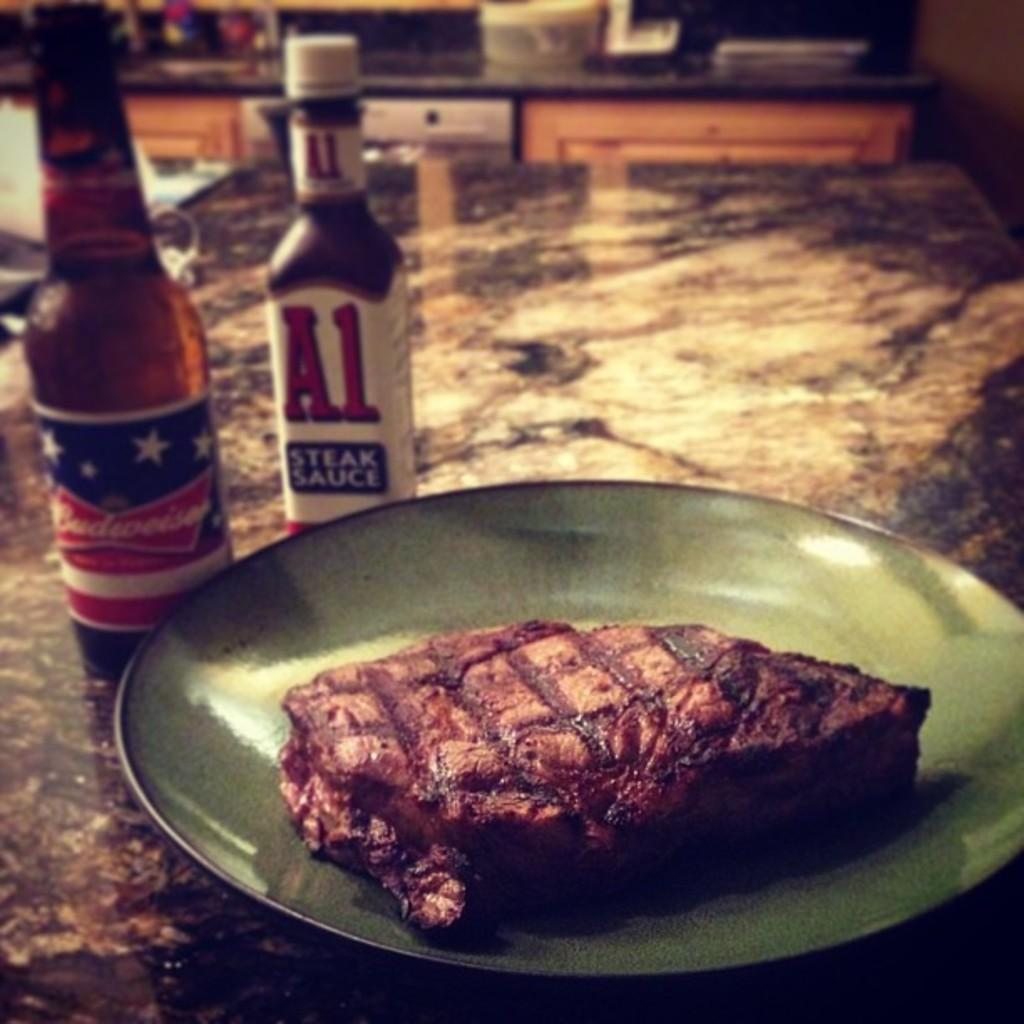<image>
Relay a brief, clear account of the picture shown. A steak lays on a green plate next to A1 and a Budweiser 